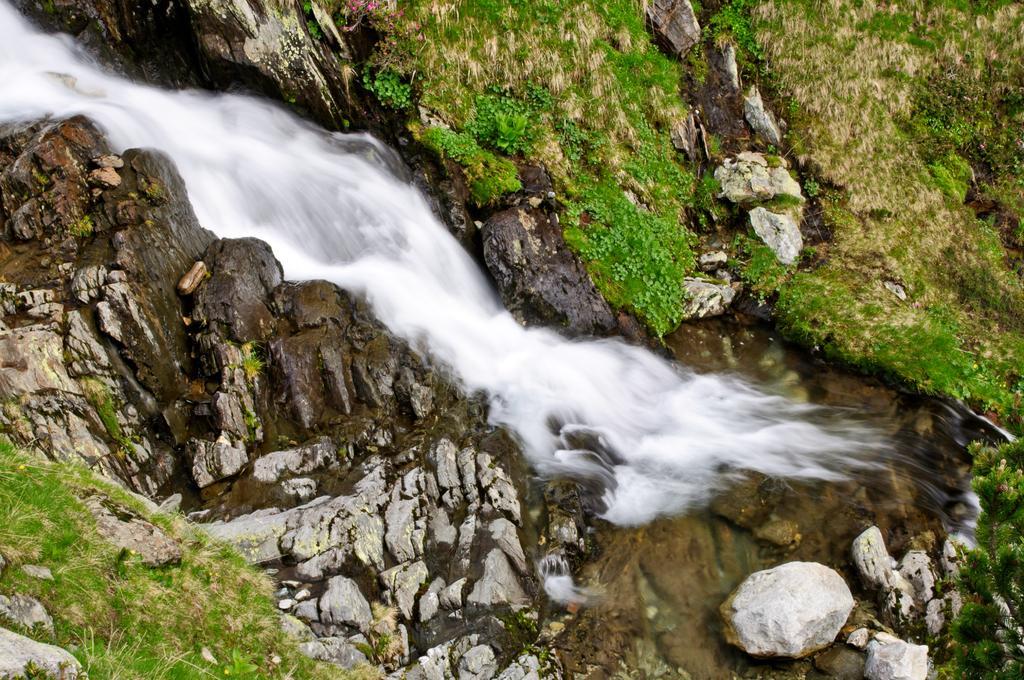Describe this image in one or two sentences. In this image I can see water in the centre and on the both sides of it I can see number of stones and grass. 